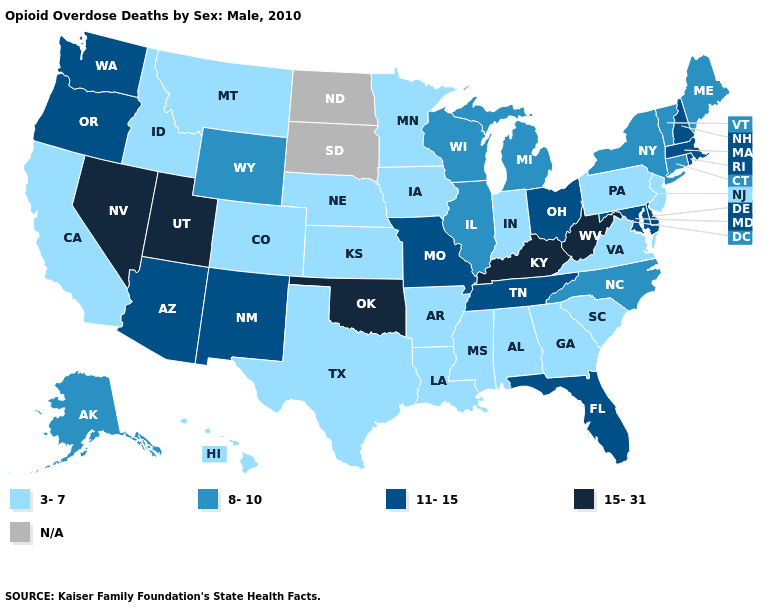Name the states that have a value in the range N/A?
Quick response, please. North Dakota, South Dakota. Which states hav the highest value in the Northeast?
Give a very brief answer. Massachusetts, New Hampshire, Rhode Island. Name the states that have a value in the range 8-10?
Give a very brief answer. Alaska, Connecticut, Illinois, Maine, Michigan, New York, North Carolina, Vermont, Wisconsin, Wyoming. Name the states that have a value in the range 15-31?
Concise answer only. Kentucky, Nevada, Oklahoma, Utah, West Virginia. Name the states that have a value in the range N/A?
Keep it brief. North Dakota, South Dakota. Which states have the lowest value in the USA?
Short answer required. Alabama, Arkansas, California, Colorado, Georgia, Hawaii, Idaho, Indiana, Iowa, Kansas, Louisiana, Minnesota, Mississippi, Montana, Nebraska, New Jersey, Pennsylvania, South Carolina, Texas, Virginia. Does Nevada have the lowest value in the West?
Keep it brief. No. What is the value of Colorado?
Be succinct. 3-7. What is the value of South Dakota?
Concise answer only. N/A. What is the value of Utah?
Keep it brief. 15-31. Name the states that have a value in the range 11-15?
Concise answer only. Arizona, Delaware, Florida, Maryland, Massachusetts, Missouri, New Hampshire, New Mexico, Ohio, Oregon, Rhode Island, Tennessee, Washington. What is the highest value in the West ?
Answer briefly. 15-31. Name the states that have a value in the range 11-15?
Keep it brief. Arizona, Delaware, Florida, Maryland, Massachusetts, Missouri, New Hampshire, New Mexico, Ohio, Oregon, Rhode Island, Tennessee, Washington. 